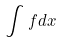Convert formula to latex. <formula><loc_0><loc_0><loc_500><loc_500>\int f d x</formula> 